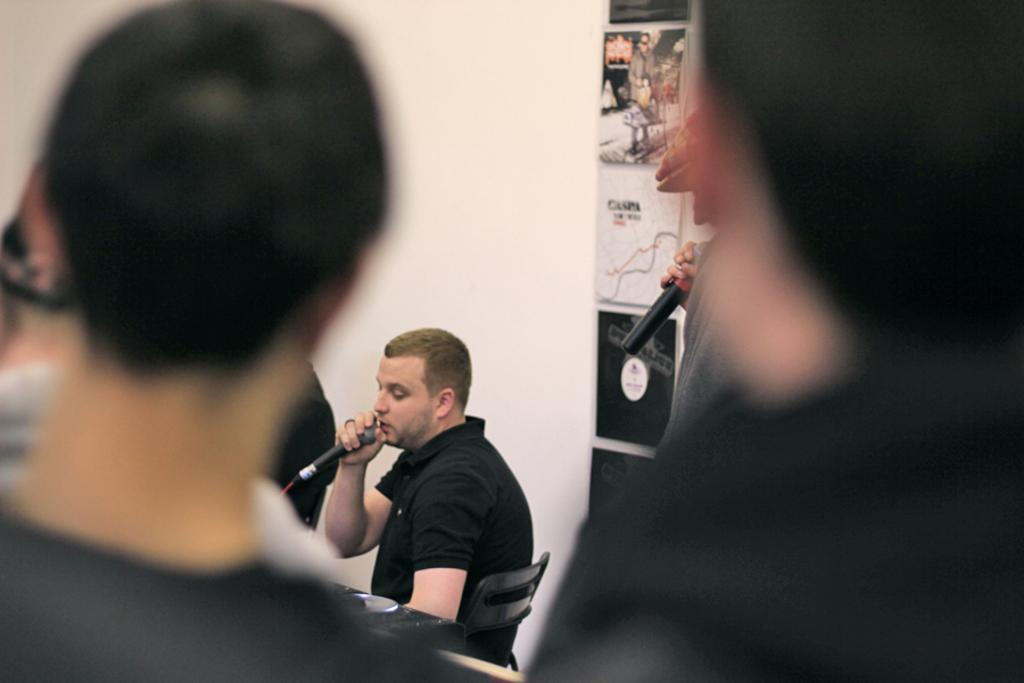What are the people in the image doing? There are people standing and one person sitting in the image. What is the person sitting wearing? The person sitting is wearing a black t-shirt. What is the person sitting holding? The person sitting is holding a microphone. What can be seen in the background of the image? There is a white wall in the background. How many people are holding microphones in the image? There are two people holding microphones in the image. What type of iron can be seen floating in space in the image? There is no iron or space present in the image; it features people standing and sitting with microphones. How does the person sitting in the image relate to the concept of death? There is no reference to death in the image, and the person sitting is simply holding a microphone. 